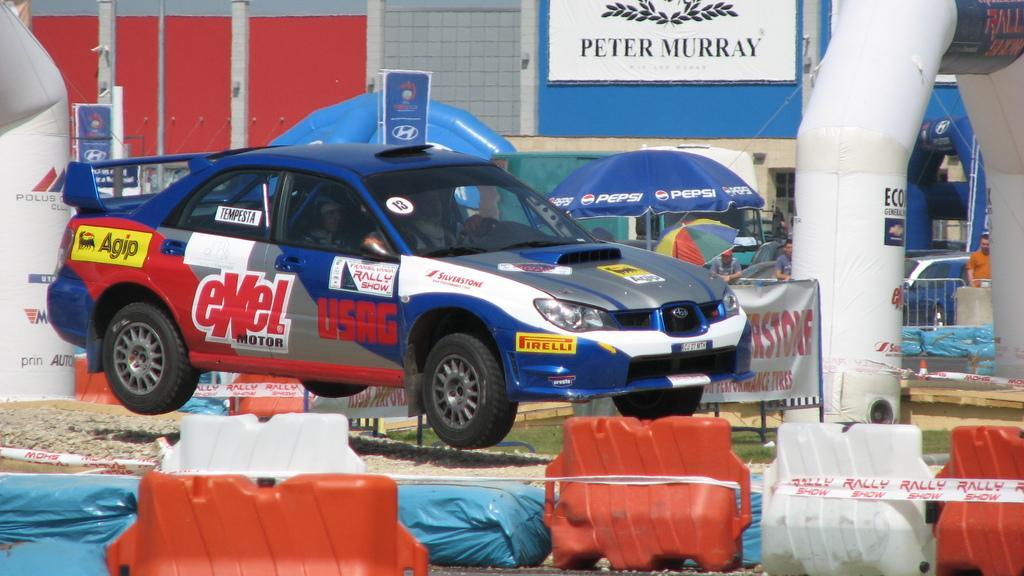Please provide a concise description of this image. In this image there is a car, there are two persons sitting in the car, there is sand, there are objects on the ground, there are boards, there is text on the boards, there are two men standing, there is a man standing towards the right of the image, there is an object towards the right of the image, there are poles towards the top of the image, there is a wall towards the top of the image, there are poles towards the top of the image, there is an object towards the left of the image, there is an umbrella, there is text on umbrella. 